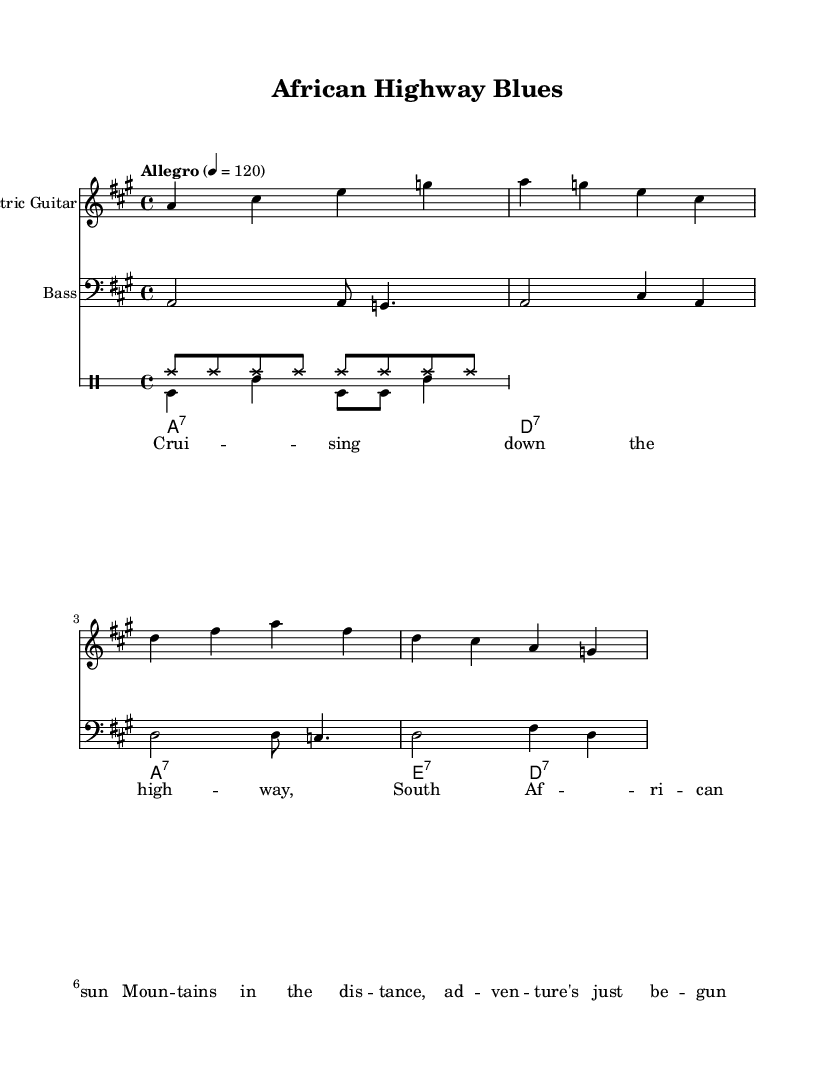What is the key signature of this music? The key signature indicates that the piece is in A major, which has three sharps: F sharp, C sharp, and G sharp. This can be deduced by looking at the opening section of the sheet music where the key signature is clearly displayed.
Answer: A major What is the time signature of this piece? The time signature shown in the music sheet is 4/4, which means there are four beats in each measure and the quarter note gets one beat. This is indicated at the beginning of the score, next to the key signature.
Answer: 4/4 What is the tempo marking of this song? The tempo marking in the sheet music specifies "Allegro," which suggests a fast, lively pace. The metronome marking of 120 beats per minute is also stated in the score, indicating how quickly the music should be played.
Answer: Allegro What instruments are featured in this score? The music score features an electric guitar, bass, drums, and an organ. Each instrument is labeled at the beginning of its corresponding staff, as indicated in the score layout.
Answer: Electric guitar, bass, drums, organ How many measures are in the verse? The verse presents a total of four measures, as can be counted visually in the lyric section of the music where each line corresponds to a measure. This count is verified by observing the placement of the lyrics and musical symbols.
Answer: Four measures What is the function of the organ in this piece? The organ provides harmonic support or chordal accompaniment throughout the song. The chord progression indicated in the organ staff shows the chords being played in a rhythmic pattern, creating a foundation for the guitar and other instruments.
Answer: Harmonic support What style of music does this piece represent? This music represents the Electric Blues genre, characterized by its upbeat tempo and instrumentation, including the use of electric guitar and rhythmic bass. The lyrical content and structure align with traditional blues themes, making it distinctively identifiable.
Answer: Electric Blues 